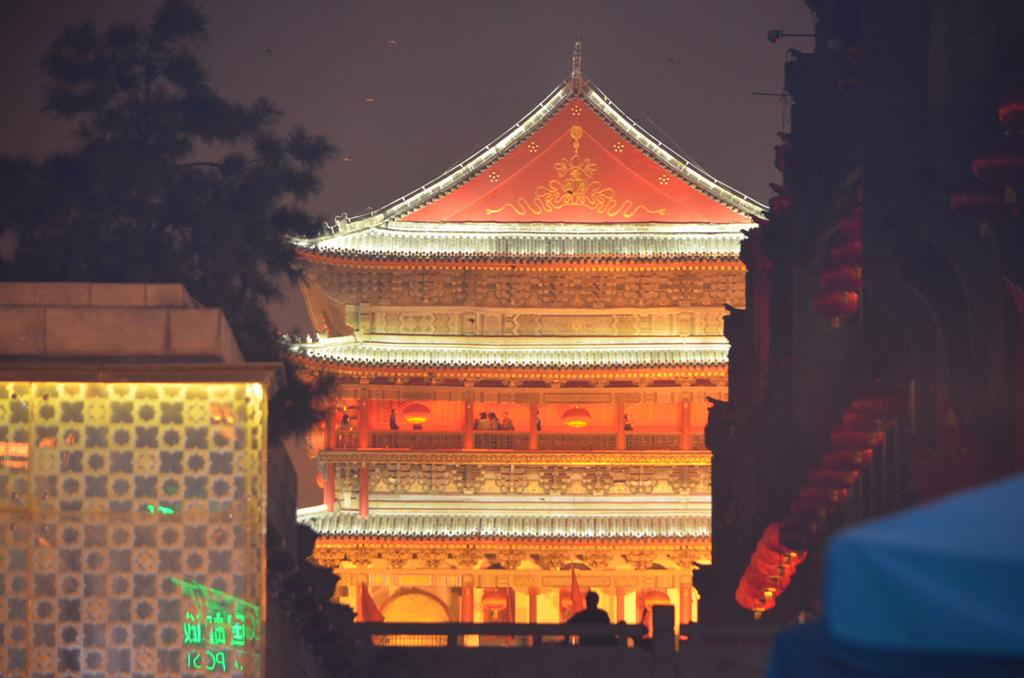How many buildings can be seen in the image? There are three buildings in the image. What is special about the building in the backdrop? The building in the backdrop is arranged with lights. What type of vegetation is on the left side of the image? There is a tree on the left side of the image. What is the condition of the sky in the image? The sky is clear in the image. What type of cloth is draped over the volcano in the image? There is no volcano present in the image, and therefore no cloth draped over it. 